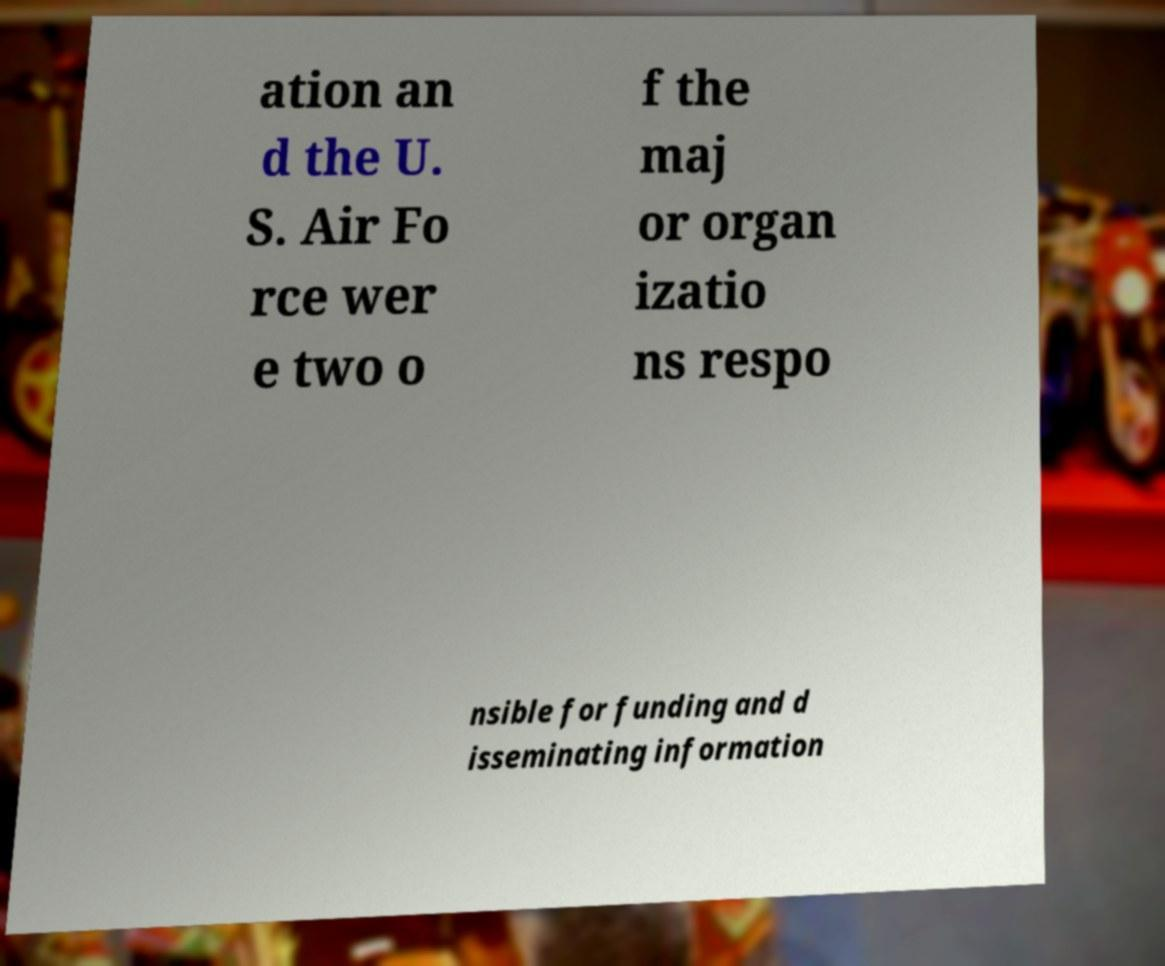I need the written content from this picture converted into text. Can you do that? ation an d the U. S. Air Fo rce wer e two o f the maj or organ izatio ns respo nsible for funding and d isseminating information 